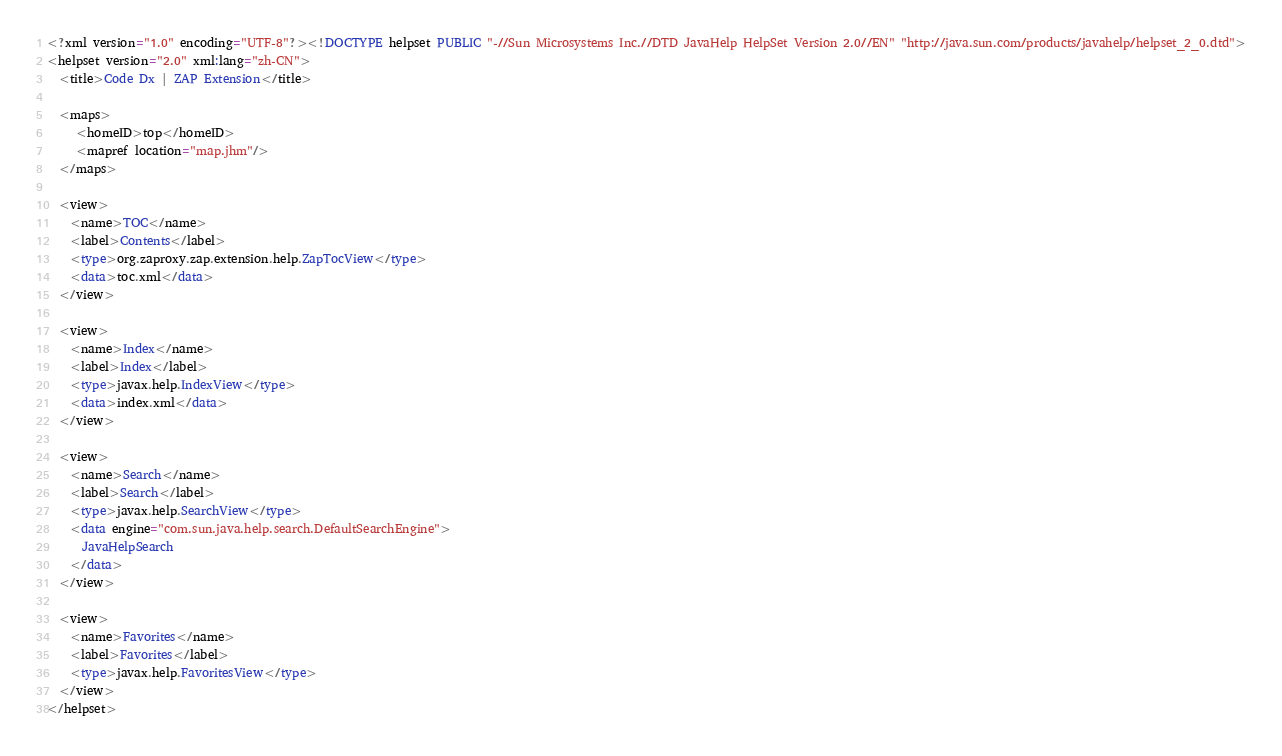Convert code to text. <code><loc_0><loc_0><loc_500><loc_500><_Haskell_><?xml version="1.0" encoding="UTF-8"?><!DOCTYPE helpset PUBLIC "-//Sun Microsystems Inc.//DTD JavaHelp HelpSet Version 2.0//EN" "http://java.sun.com/products/javahelp/helpset_2_0.dtd">
<helpset version="2.0" xml:lang="zh-CN">
  <title>Code Dx | ZAP Extension</title>

  <maps>
     <homeID>top</homeID>
     <mapref location="map.jhm"/>
  </maps>

  <view>
    <name>TOC</name>
    <label>Contents</label>
    <type>org.zaproxy.zap.extension.help.ZapTocView</type>
    <data>toc.xml</data>
  </view>

  <view>
    <name>Index</name>
    <label>Index</label>
    <type>javax.help.IndexView</type>
    <data>index.xml</data>
  </view>

  <view>
    <name>Search</name>
    <label>Search</label>
    <type>javax.help.SearchView</type>
    <data engine="com.sun.java.help.search.DefaultSearchEngine">
      JavaHelpSearch
    </data>
  </view>

  <view>
    <name>Favorites</name>
    <label>Favorites</label>
    <type>javax.help.FavoritesView</type>
  </view>
</helpset></code> 